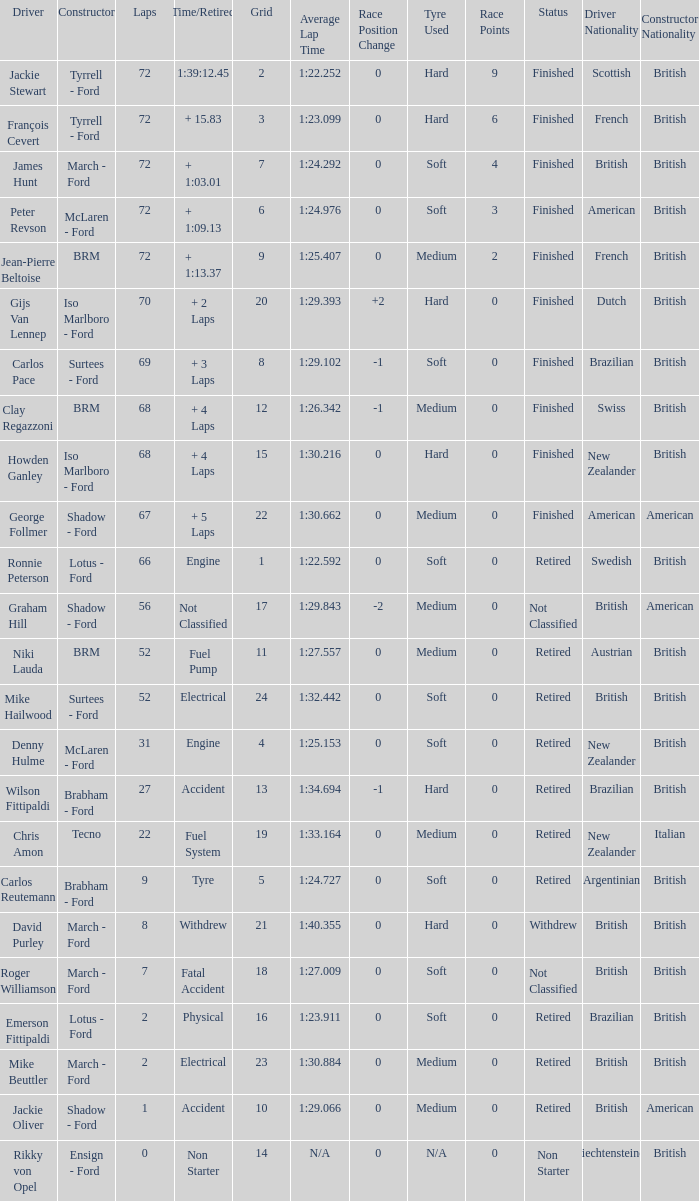What is the top lap that had a tyre time? 9.0. Can you parse all the data within this table? {'header': ['Driver', 'Constructor', 'Laps', 'Time/Retired', 'Grid', 'Average Lap Time', 'Race Position Change', 'Tyre Used', 'Race Points', 'Status', 'Driver Nationality', 'Constructor Nationality'], 'rows': [['Jackie Stewart', 'Tyrrell - Ford', '72', '1:39:12.45', '2', '1:22.252', '0', 'Hard', '9', 'Finished', 'Scottish', 'British'], ['François Cevert', 'Tyrrell - Ford', '72', '+ 15.83', '3', '1:23.099', '0', 'Hard', '6', 'Finished', 'French', 'British'], ['James Hunt', 'March - Ford', '72', '+ 1:03.01', '7', '1:24.292', '0', 'Soft', '4', 'Finished', 'British', 'British'], ['Peter Revson', 'McLaren - Ford', '72', '+ 1:09.13', '6', '1:24.976', '0', 'Soft', '3', 'Finished', 'American', 'British'], ['Jean-Pierre Beltoise', 'BRM', '72', '+ 1:13.37', '9', '1:25.407', '0', 'Medium', '2', 'Finished', 'French', 'British'], ['Gijs Van Lennep', 'Iso Marlboro - Ford', '70', '+ 2 Laps', '20', '1:29.393', '+2', 'Hard', '0', 'Finished', 'Dutch', 'British'], ['Carlos Pace', 'Surtees - Ford', '69', '+ 3 Laps', '8', '1:29.102', '-1', 'Soft', '0', 'Finished', 'Brazilian', 'British'], ['Clay Regazzoni', 'BRM', '68', '+ 4 Laps', '12', '1:26.342', '-1', 'Medium', '0', 'Finished', 'Swiss', 'British'], ['Howden Ganley', 'Iso Marlboro - Ford', '68', '+ 4 Laps', '15', '1:30.216', '0', 'Hard', '0', 'Finished', 'New Zealander', 'British'], ['George Follmer', 'Shadow - Ford', '67', '+ 5 Laps', '22', '1:30.662', '0', 'Medium', '0', 'Finished', 'American', 'American'], ['Ronnie Peterson', 'Lotus - Ford', '66', 'Engine', '1', '1:22.592', '0', 'Soft', '0', 'Retired', 'Swedish', 'British'], ['Graham Hill', 'Shadow - Ford', '56', 'Not Classified', '17', '1:29.843', '-2', 'Medium', '0', 'Not Classified', 'British', 'American'], ['Niki Lauda', 'BRM', '52', 'Fuel Pump', '11', '1:27.557', '0', 'Medium', '0', 'Retired', 'Austrian', 'British'], ['Mike Hailwood', 'Surtees - Ford', '52', 'Electrical', '24', '1:32.442', '0', 'Soft', '0', 'Retired', 'British', 'British'], ['Denny Hulme', 'McLaren - Ford', '31', 'Engine', '4', '1:25.153', '0', 'Soft', '0', 'Retired', 'New Zealander', 'British'], ['Wilson Fittipaldi', 'Brabham - Ford', '27', 'Accident', '13', '1:34.694', '-1', 'Hard', '0', 'Retired', 'Brazilian', 'British'], ['Chris Amon', 'Tecno', '22', 'Fuel System', '19', '1:33.164', '0', 'Medium', '0', 'Retired', 'New Zealander', 'Italian'], ['Carlos Reutemann', 'Brabham - Ford', '9', 'Tyre', '5', '1:24.727', '0', 'Soft', '0', 'Retired', 'Argentinian', 'British'], ['David Purley', 'March - Ford', '8', 'Withdrew', '21', '1:40.355', '0', 'Hard', '0', 'Withdrew', 'British', 'British'], ['Roger Williamson', 'March - Ford', '7', 'Fatal Accident', '18', '1:27.009', '0', 'Soft', '0', 'Not Classified', 'British', 'British'], ['Emerson Fittipaldi', 'Lotus - Ford', '2', 'Physical', '16', '1:23.911', '0', 'Soft', '0', 'Retired', 'Brazilian', 'British'], ['Mike Beuttler', 'March - Ford', '2', 'Electrical', '23', '1:30.884', '0', 'Medium', '0', 'Retired', 'British', 'British'], ['Jackie Oliver', 'Shadow - Ford', '1', 'Accident', '10', '1:29.066', '0', 'Medium', '0', 'Retired', 'British', 'American'], ['Rikky von Opel', 'Ensign - Ford', '0', 'Non Starter', '14', 'N/A', '0', 'N/A', '0', 'Non Starter', 'Liechtensteiner', 'British']]} 